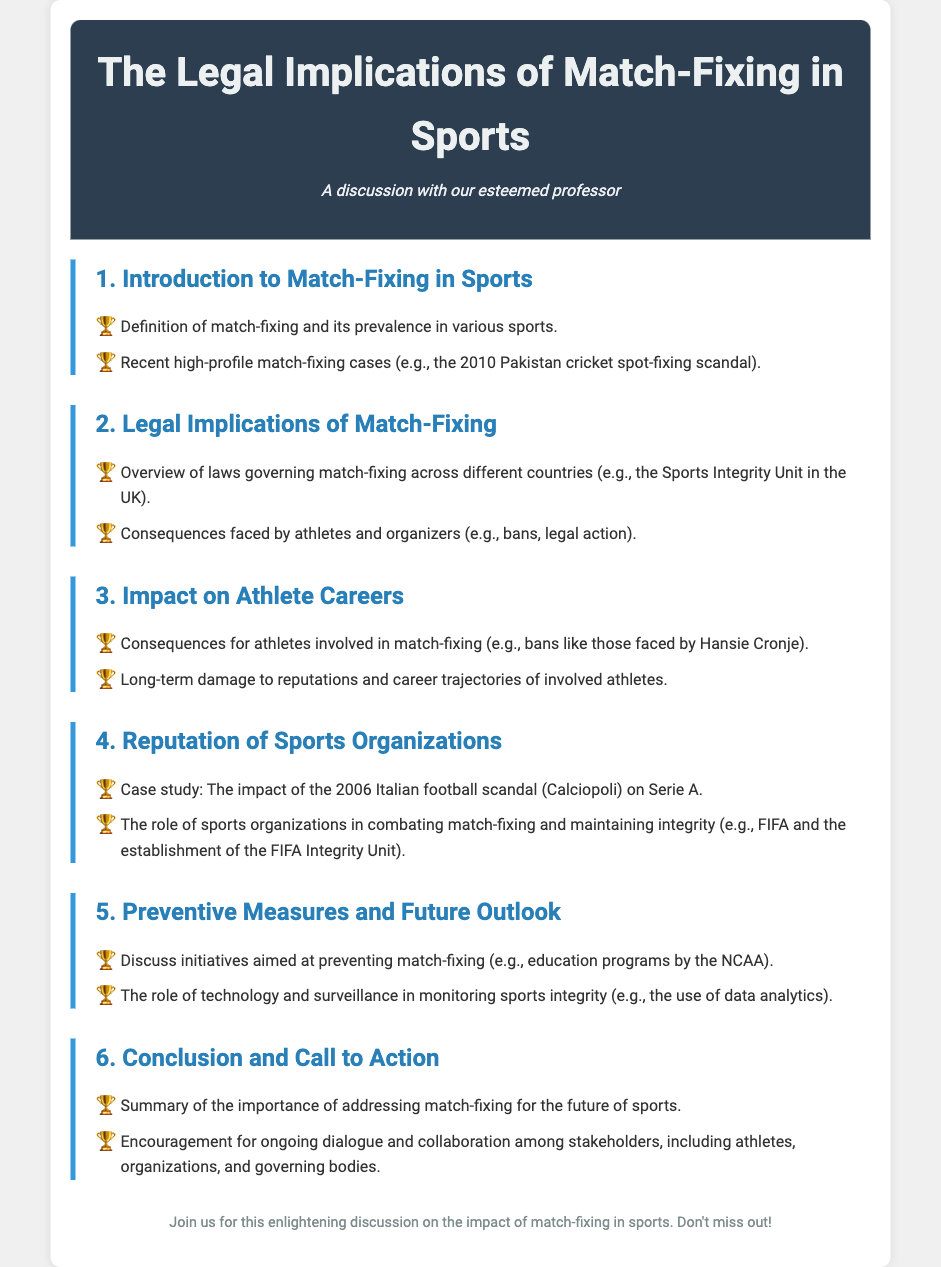What is match-fixing? Match-fixing is defined in the document, pertaining to its prevalence in various sports.
Answer: Definition of match-fixing What scandal is mentioned in context with Pakistan cricket? The document references the 2010 Pakistan cricket spot-fixing scandal as a recent high-profile case.
Answer: 2010 Pakistan cricket spot-fixing scandal What are the consequences faced by athletes involved in match-fixing? The document outlines that athletes can face bans and legal action as consequences.
Answer: Bans, legal action Which infamous case impacted Serie A? The Calciopoli scandal is highlighted as a significant case affecting Serie A.
Answer: Calciopoli What organization is responsible for overseeing match-fixing laws in the UK? The Sports Integrity Unit is mentioned as a governing body in the UK.
Answer: Sports Integrity Unit What measures are discussed for preventing match-fixing? The agenda includes discussing education programs and initiatives aimed at combating match-fixing.
Answer: Education programs How has technology influenced monitoring of sports integrity? The document states that technology plays a role in monitoring integrity through data analytics.
Answer: Data analytics What was the focus of initiatives discussed in the agenda? The focus is on initiatives aimed at preventing match-fixing outlined in the agenda.
Answer: Preventing match-fixing 